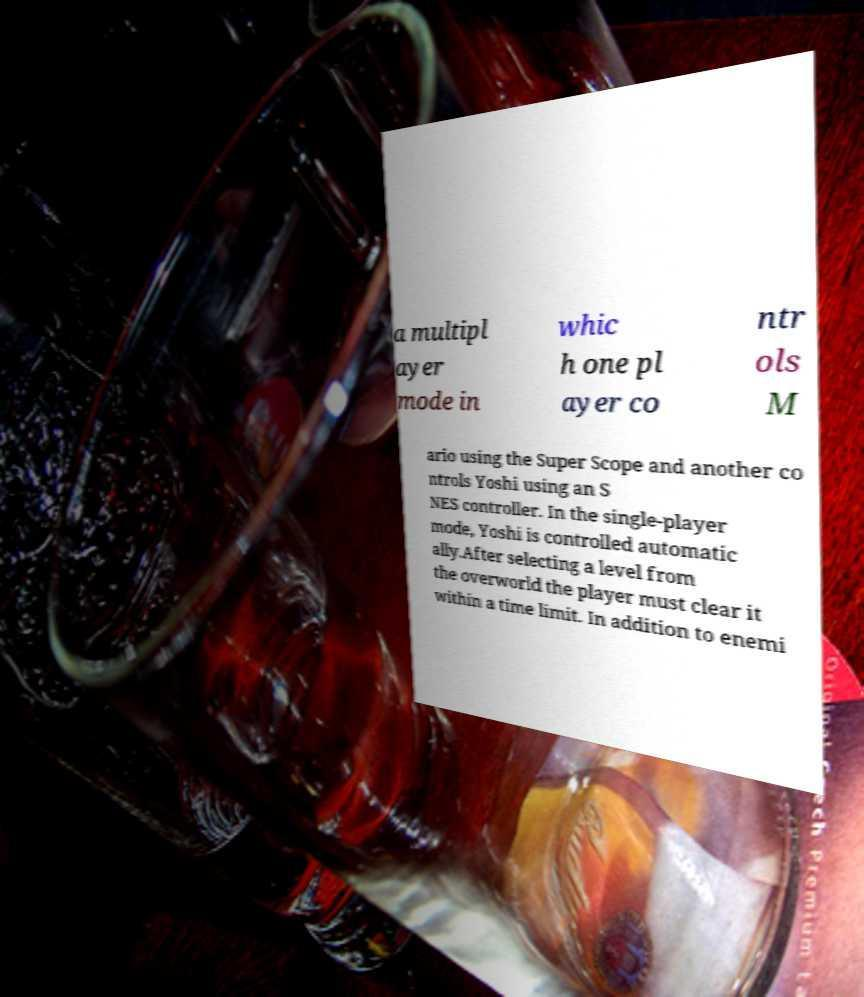What messages or text are displayed in this image? I need them in a readable, typed format. a multipl ayer mode in whic h one pl ayer co ntr ols M ario using the Super Scope and another co ntrols Yoshi using an S NES controller. In the single-player mode, Yoshi is controlled automatic ally.After selecting a level from the overworld the player must clear it within a time limit. In addition to enemi 